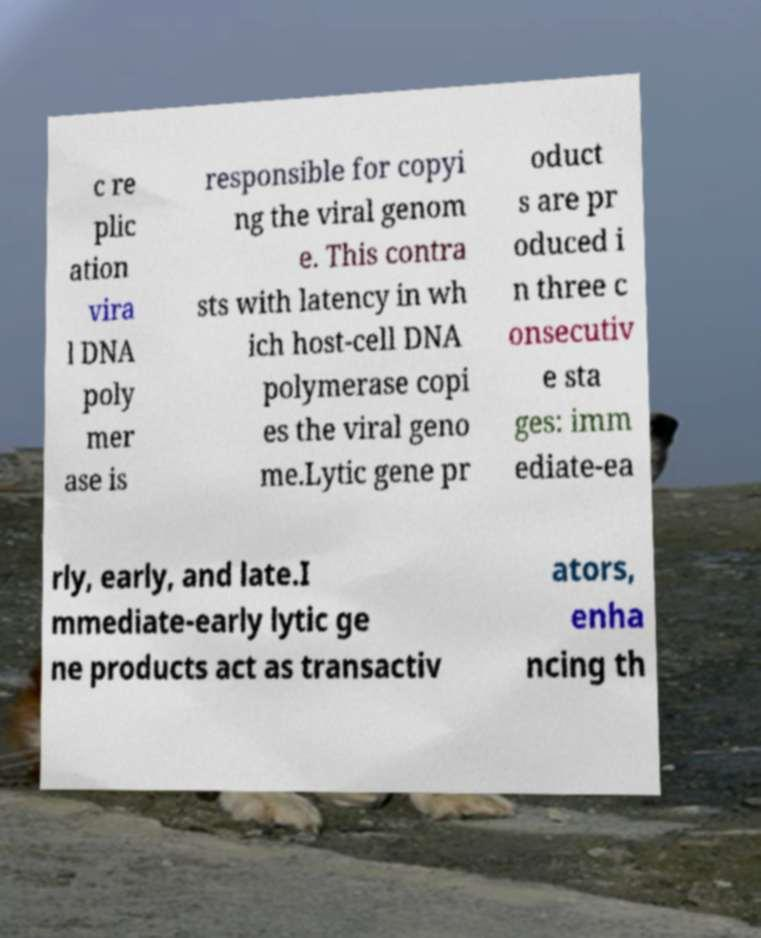Please read and relay the text visible in this image. What does it say? c re plic ation vira l DNA poly mer ase is responsible for copyi ng the viral genom e. This contra sts with latency in wh ich host-cell DNA polymerase copi es the viral geno me.Lytic gene pr oduct s are pr oduced i n three c onsecutiv e sta ges: imm ediate-ea rly, early, and late.I mmediate-early lytic ge ne products act as transactiv ators, enha ncing th 